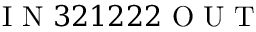Convert formula to latex. <formula><loc_0><loc_0><loc_500><loc_500>I N 3 2 1 2 2 2 O U T</formula> 